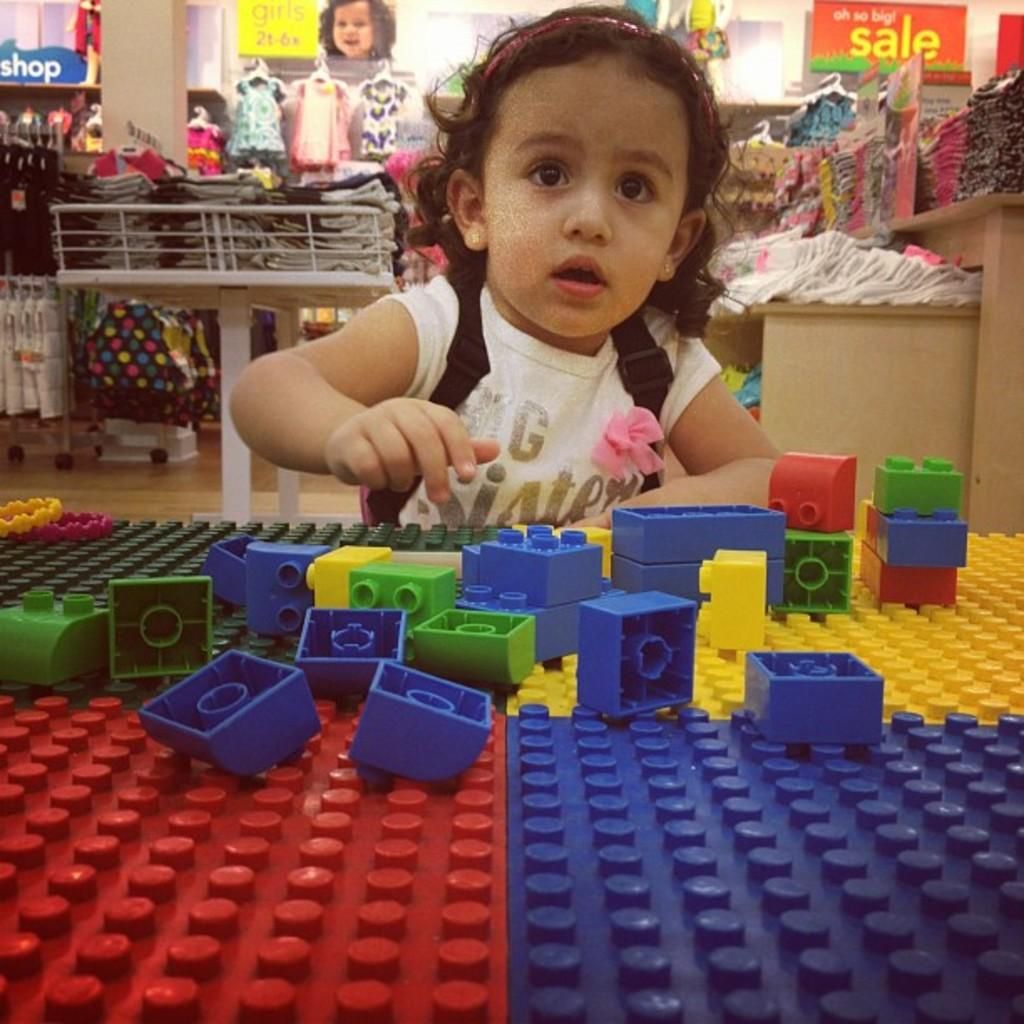What is the main subject of the image? The main subject of the image is a baby. What is the baby doing in the image? The baby is playing with color blocks. Can you describe the background of the image? There are plenty of kids wear visible in the background. How many baskets are being used by the baby to play with the color blocks? There is no mention of baskets in the image; the baby is playing with color blocks directly. 